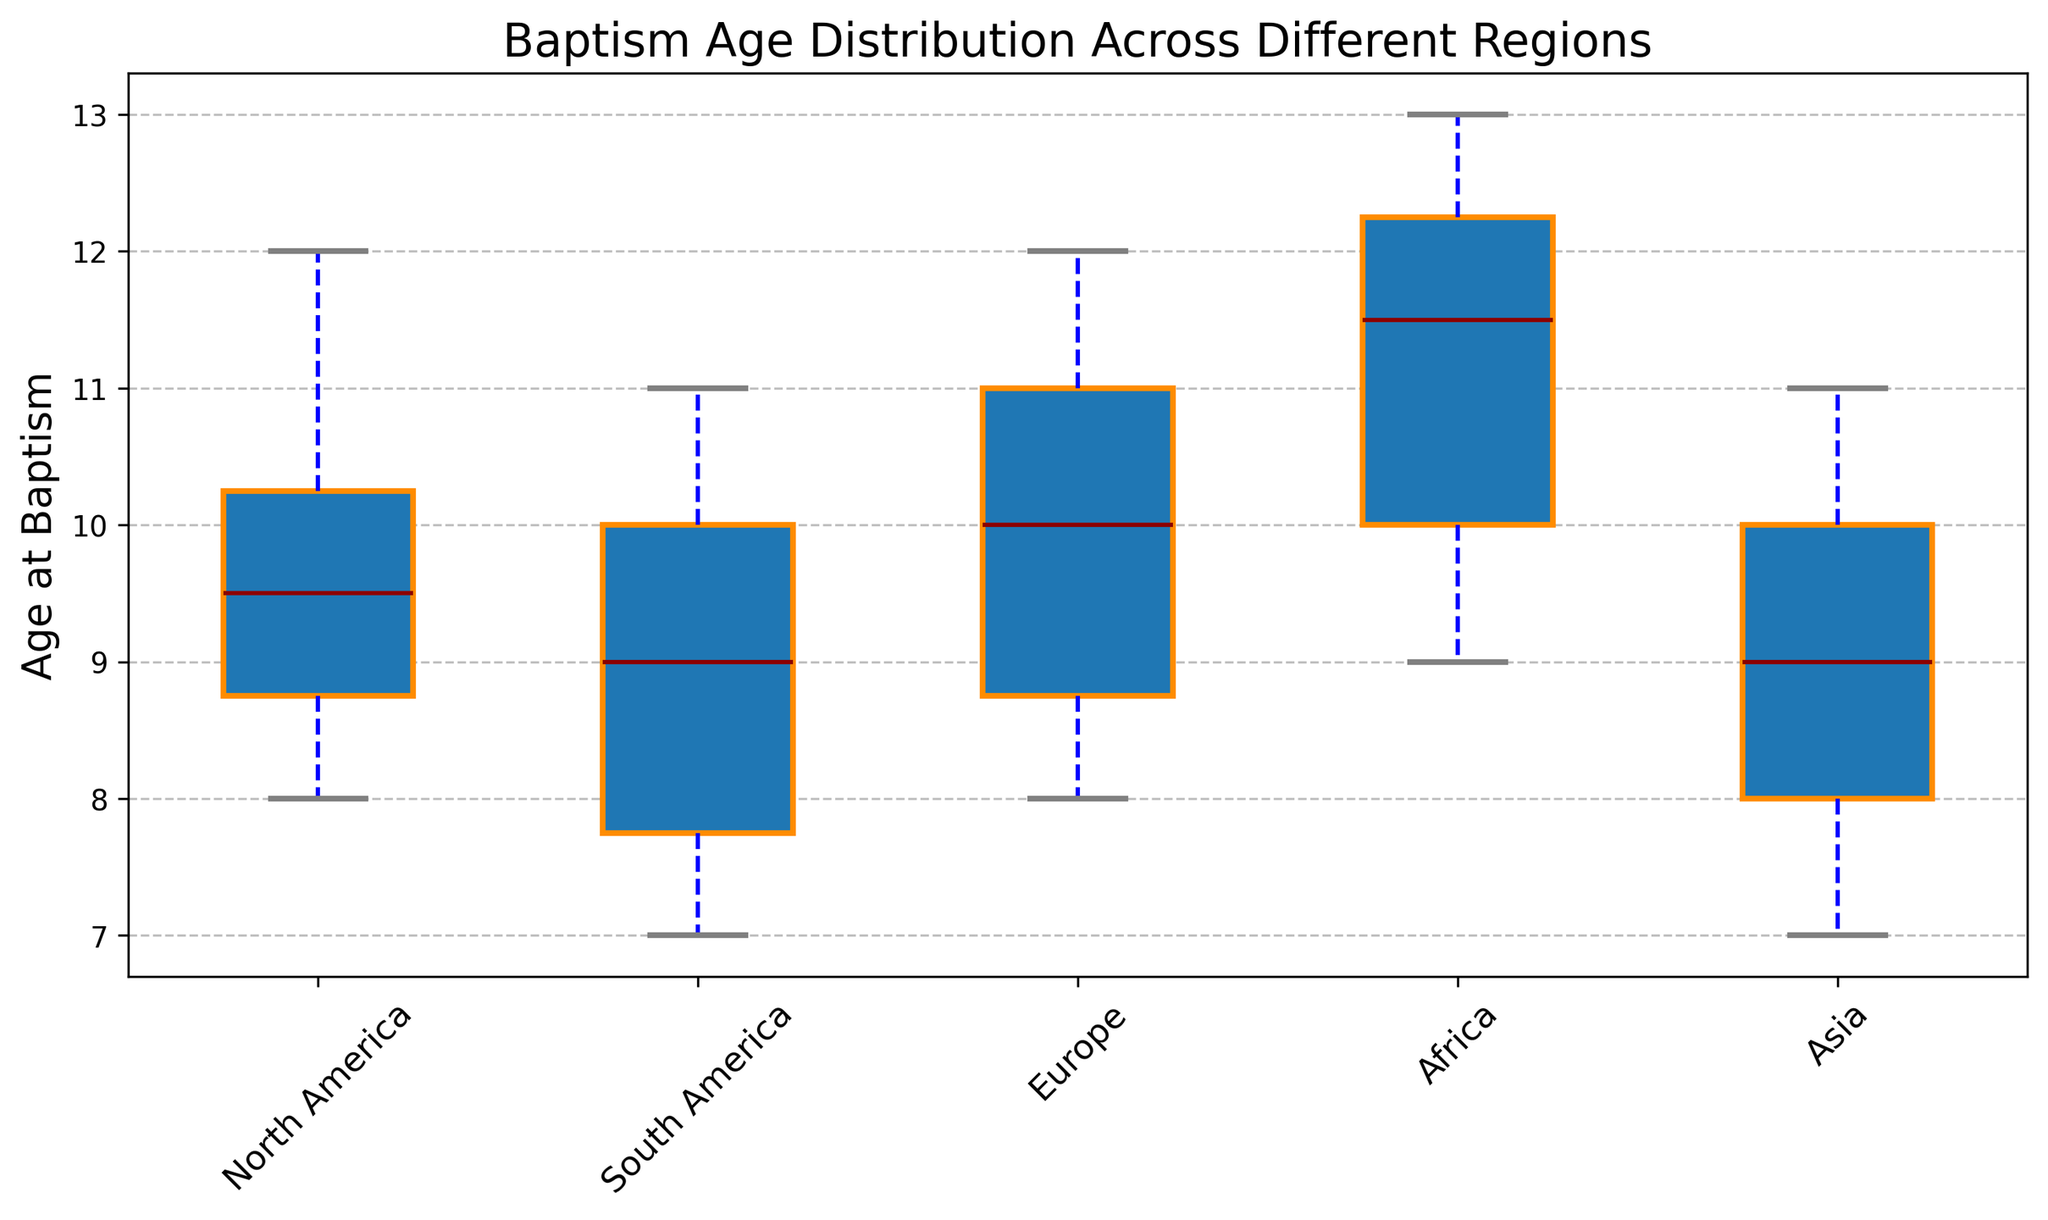What's the median baptism age in North America? The box plot's line inside the box represents the median. For the North America box, this line is at 10.
Answer: 10 Which region has the highest maximum baptism age? The top whisker indicates the highest value in the dataset. For Africa, the top whisker is at 13, which is the highest among all regions shown.
Answer: Africa Which region has the smallest interquartile range (IQR) for baptism age? The IQR is represented by the height of the box. The smallest box is in Asia, indicating the smallest IQR.
Answer: Asia What is the range of baptism ages in South America? The range is the difference between the highest and lowest whiskers. For South America, the lowest is at 7 and the highest is at 11, so the range is 11-7=4.
Answer: 4 Compare the median baptism age of Europe and Asia. Which is higher? The median is indicated by the line inside the box. For Europe, it’s 10, and for Asia, it’s 9. Thus, Europe has the higher median.
Answer: Europe Which regions have an upper quartile (75th percentile) above age 10? The upper quartile is indicated by the top edge of the box. For North America, Europe, and Africa, this edge is above 10.
Answer: North America, Europe, Africa Is the distribution of baptism ages more spread out in Africa or North America? The spread of the data can be seen by the length of the whiskers and the height of the box. Africa’s whiskers and box are longer compared to North America’s, showing more spread out data.
Answer: Africa Do any regions show an outlier in baptism age? Outliers are typically shown as dots outside the whiskers. There are no dots present outside the whiskers for any region, indicating no outliers in the data.
Answer: No What's the median difference in baptism age between Africa and South America? The median for Africa is 12, and for South America, it’s 9. The difference is 12-9=3.
Answer: 3 In which region are the baptism ages most tightly clustered? The tight clustering can be identified by the shortest whiskers and smallest box. Asia has the shortest whiskers and the smallest box, indicating tightly clustered data.
Answer: Asia 